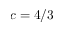<formula> <loc_0><loc_0><loc_500><loc_500>c = 4 / 3</formula> 